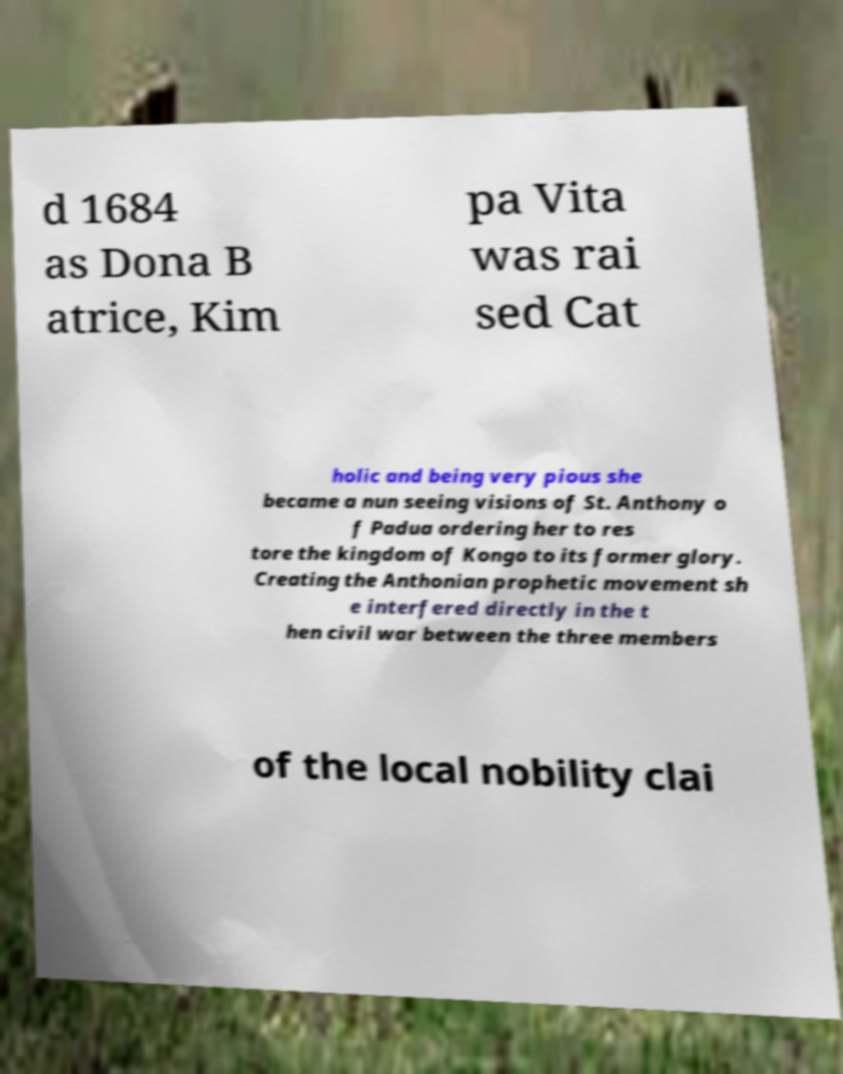I need the written content from this picture converted into text. Can you do that? d 1684 as Dona B atrice, Kim pa Vita was rai sed Cat holic and being very pious she became a nun seeing visions of St. Anthony o f Padua ordering her to res tore the kingdom of Kongo to its former glory. Creating the Anthonian prophetic movement sh e interfered directly in the t hen civil war between the three members of the local nobility clai 